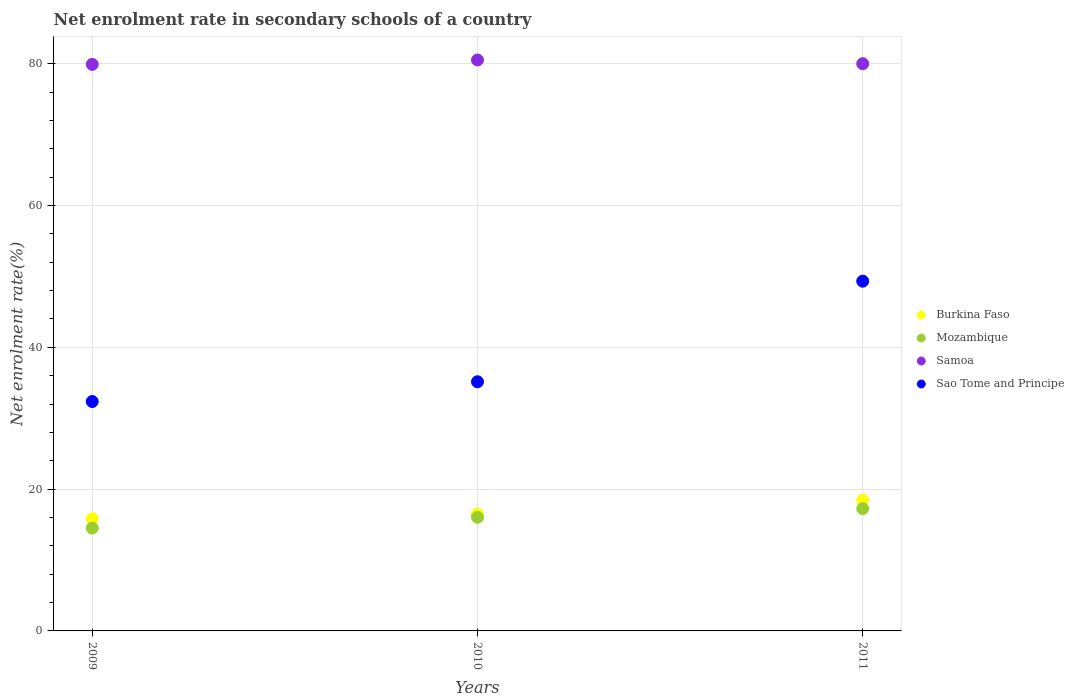How many different coloured dotlines are there?
Provide a short and direct response. 4. Is the number of dotlines equal to the number of legend labels?
Offer a terse response. Yes. What is the net enrolment rate in secondary schools in Burkina Faso in 2011?
Offer a very short reply. 18.45. Across all years, what is the maximum net enrolment rate in secondary schools in Samoa?
Your answer should be very brief. 80.53. Across all years, what is the minimum net enrolment rate in secondary schools in Samoa?
Offer a very short reply. 79.91. In which year was the net enrolment rate in secondary schools in Samoa maximum?
Your answer should be very brief. 2010. What is the total net enrolment rate in secondary schools in Sao Tome and Principe in the graph?
Make the answer very short. 116.84. What is the difference between the net enrolment rate in secondary schools in Burkina Faso in 2009 and that in 2011?
Provide a succinct answer. -2.62. What is the difference between the net enrolment rate in secondary schools in Samoa in 2011 and the net enrolment rate in secondary schools in Burkina Faso in 2009?
Your answer should be very brief. 64.18. What is the average net enrolment rate in secondary schools in Burkina Faso per year?
Ensure brevity in your answer.  16.92. In the year 2009, what is the difference between the net enrolment rate in secondary schools in Mozambique and net enrolment rate in secondary schools in Burkina Faso?
Make the answer very short. -1.31. What is the ratio of the net enrolment rate in secondary schools in Mozambique in 2009 to that in 2011?
Offer a very short reply. 0.84. What is the difference between the highest and the second highest net enrolment rate in secondary schools in Mozambique?
Offer a terse response. 1.23. What is the difference between the highest and the lowest net enrolment rate in secondary schools in Samoa?
Make the answer very short. 0.62. Is it the case that in every year, the sum of the net enrolment rate in secondary schools in Sao Tome and Principe and net enrolment rate in secondary schools in Samoa  is greater than the sum of net enrolment rate in secondary schools in Mozambique and net enrolment rate in secondary schools in Burkina Faso?
Your answer should be very brief. Yes. Is it the case that in every year, the sum of the net enrolment rate in secondary schools in Samoa and net enrolment rate in secondary schools in Burkina Faso  is greater than the net enrolment rate in secondary schools in Mozambique?
Provide a succinct answer. Yes. Does the net enrolment rate in secondary schools in Samoa monotonically increase over the years?
Offer a very short reply. No. Is the net enrolment rate in secondary schools in Mozambique strictly less than the net enrolment rate in secondary schools in Samoa over the years?
Give a very brief answer. Yes. How many dotlines are there?
Your answer should be very brief. 4. How many legend labels are there?
Offer a terse response. 4. How are the legend labels stacked?
Offer a terse response. Vertical. What is the title of the graph?
Offer a terse response. Net enrolment rate in secondary schools of a country. What is the label or title of the Y-axis?
Ensure brevity in your answer.  Net enrolment rate(%). What is the Net enrolment rate(%) of Burkina Faso in 2009?
Offer a terse response. 15.82. What is the Net enrolment rate(%) of Mozambique in 2009?
Give a very brief answer. 14.51. What is the Net enrolment rate(%) in Samoa in 2009?
Offer a terse response. 79.91. What is the Net enrolment rate(%) in Sao Tome and Principe in 2009?
Give a very brief answer. 32.36. What is the Net enrolment rate(%) of Burkina Faso in 2010?
Your response must be concise. 16.48. What is the Net enrolment rate(%) of Mozambique in 2010?
Offer a terse response. 16.03. What is the Net enrolment rate(%) in Samoa in 2010?
Provide a short and direct response. 80.53. What is the Net enrolment rate(%) in Sao Tome and Principe in 2010?
Offer a terse response. 35.14. What is the Net enrolment rate(%) in Burkina Faso in 2011?
Ensure brevity in your answer.  18.45. What is the Net enrolment rate(%) of Mozambique in 2011?
Make the answer very short. 17.25. What is the Net enrolment rate(%) of Samoa in 2011?
Ensure brevity in your answer.  80.01. What is the Net enrolment rate(%) of Sao Tome and Principe in 2011?
Provide a short and direct response. 49.33. Across all years, what is the maximum Net enrolment rate(%) in Burkina Faso?
Offer a very short reply. 18.45. Across all years, what is the maximum Net enrolment rate(%) in Mozambique?
Offer a very short reply. 17.25. Across all years, what is the maximum Net enrolment rate(%) of Samoa?
Ensure brevity in your answer.  80.53. Across all years, what is the maximum Net enrolment rate(%) in Sao Tome and Principe?
Your answer should be very brief. 49.33. Across all years, what is the minimum Net enrolment rate(%) in Burkina Faso?
Provide a succinct answer. 15.82. Across all years, what is the minimum Net enrolment rate(%) in Mozambique?
Your response must be concise. 14.51. Across all years, what is the minimum Net enrolment rate(%) in Samoa?
Your response must be concise. 79.91. Across all years, what is the minimum Net enrolment rate(%) in Sao Tome and Principe?
Give a very brief answer. 32.36. What is the total Net enrolment rate(%) in Burkina Faso in the graph?
Offer a terse response. 50.75. What is the total Net enrolment rate(%) in Mozambique in the graph?
Your response must be concise. 47.79. What is the total Net enrolment rate(%) of Samoa in the graph?
Provide a short and direct response. 240.45. What is the total Net enrolment rate(%) in Sao Tome and Principe in the graph?
Your answer should be very brief. 116.84. What is the difference between the Net enrolment rate(%) in Burkina Faso in 2009 and that in 2010?
Offer a very short reply. -0.65. What is the difference between the Net enrolment rate(%) in Mozambique in 2009 and that in 2010?
Make the answer very short. -1.52. What is the difference between the Net enrolment rate(%) in Samoa in 2009 and that in 2010?
Your answer should be very brief. -0.62. What is the difference between the Net enrolment rate(%) of Sao Tome and Principe in 2009 and that in 2010?
Provide a short and direct response. -2.79. What is the difference between the Net enrolment rate(%) of Burkina Faso in 2009 and that in 2011?
Your answer should be compact. -2.62. What is the difference between the Net enrolment rate(%) in Mozambique in 2009 and that in 2011?
Your answer should be very brief. -2.74. What is the difference between the Net enrolment rate(%) in Samoa in 2009 and that in 2011?
Offer a very short reply. -0.1. What is the difference between the Net enrolment rate(%) in Sao Tome and Principe in 2009 and that in 2011?
Make the answer very short. -16.98. What is the difference between the Net enrolment rate(%) of Burkina Faso in 2010 and that in 2011?
Give a very brief answer. -1.97. What is the difference between the Net enrolment rate(%) of Mozambique in 2010 and that in 2011?
Offer a terse response. -1.23. What is the difference between the Net enrolment rate(%) in Samoa in 2010 and that in 2011?
Your response must be concise. 0.52. What is the difference between the Net enrolment rate(%) in Sao Tome and Principe in 2010 and that in 2011?
Offer a very short reply. -14.19. What is the difference between the Net enrolment rate(%) in Burkina Faso in 2009 and the Net enrolment rate(%) in Mozambique in 2010?
Your response must be concise. -0.2. What is the difference between the Net enrolment rate(%) in Burkina Faso in 2009 and the Net enrolment rate(%) in Samoa in 2010?
Your answer should be compact. -64.71. What is the difference between the Net enrolment rate(%) in Burkina Faso in 2009 and the Net enrolment rate(%) in Sao Tome and Principe in 2010?
Provide a succinct answer. -19.32. What is the difference between the Net enrolment rate(%) of Mozambique in 2009 and the Net enrolment rate(%) of Samoa in 2010?
Ensure brevity in your answer.  -66.02. What is the difference between the Net enrolment rate(%) of Mozambique in 2009 and the Net enrolment rate(%) of Sao Tome and Principe in 2010?
Offer a terse response. -20.63. What is the difference between the Net enrolment rate(%) of Samoa in 2009 and the Net enrolment rate(%) of Sao Tome and Principe in 2010?
Ensure brevity in your answer.  44.77. What is the difference between the Net enrolment rate(%) in Burkina Faso in 2009 and the Net enrolment rate(%) in Mozambique in 2011?
Your response must be concise. -1.43. What is the difference between the Net enrolment rate(%) of Burkina Faso in 2009 and the Net enrolment rate(%) of Samoa in 2011?
Keep it short and to the point. -64.18. What is the difference between the Net enrolment rate(%) of Burkina Faso in 2009 and the Net enrolment rate(%) of Sao Tome and Principe in 2011?
Your response must be concise. -33.51. What is the difference between the Net enrolment rate(%) in Mozambique in 2009 and the Net enrolment rate(%) in Samoa in 2011?
Your answer should be very brief. -65.5. What is the difference between the Net enrolment rate(%) in Mozambique in 2009 and the Net enrolment rate(%) in Sao Tome and Principe in 2011?
Keep it short and to the point. -34.82. What is the difference between the Net enrolment rate(%) of Samoa in 2009 and the Net enrolment rate(%) of Sao Tome and Principe in 2011?
Provide a short and direct response. 30.58. What is the difference between the Net enrolment rate(%) of Burkina Faso in 2010 and the Net enrolment rate(%) of Mozambique in 2011?
Your answer should be compact. -0.78. What is the difference between the Net enrolment rate(%) in Burkina Faso in 2010 and the Net enrolment rate(%) in Samoa in 2011?
Offer a terse response. -63.53. What is the difference between the Net enrolment rate(%) of Burkina Faso in 2010 and the Net enrolment rate(%) of Sao Tome and Principe in 2011?
Make the answer very short. -32.86. What is the difference between the Net enrolment rate(%) in Mozambique in 2010 and the Net enrolment rate(%) in Samoa in 2011?
Provide a succinct answer. -63.98. What is the difference between the Net enrolment rate(%) in Mozambique in 2010 and the Net enrolment rate(%) in Sao Tome and Principe in 2011?
Offer a terse response. -33.31. What is the difference between the Net enrolment rate(%) in Samoa in 2010 and the Net enrolment rate(%) in Sao Tome and Principe in 2011?
Offer a terse response. 31.2. What is the average Net enrolment rate(%) in Burkina Faso per year?
Ensure brevity in your answer.  16.92. What is the average Net enrolment rate(%) in Mozambique per year?
Make the answer very short. 15.93. What is the average Net enrolment rate(%) of Samoa per year?
Provide a succinct answer. 80.15. What is the average Net enrolment rate(%) of Sao Tome and Principe per year?
Offer a terse response. 38.95. In the year 2009, what is the difference between the Net enrolment rate(%) of Burkina Faso and Net enrolment rate(%) of Mozambique?
Offer a very short reply. 1.31. In the year 2009, what is the difference between the Net enrolment rate(%) in Burkina Faso and Net enrolment rate(%) in Samoa?
Provide a succinct answer. -64.09. In the year 2009, what is the difference between the Net enrolment rate(%) in Burkina Faso and Net enrolment rate(%) in Sao Tome and Principe?
Your answer should be compact. -16.53. In the year 2009, what is the difference between the Net enrolment rate(%) of Mozambique and Net enrolment rate(%) of Samoa?
Your response must be concise. -65.4. In the year 2009, what is the difference between the Net enrolment rate(%) of Mozambique and Net enrolment rate(%) of Sao Tome and Principe?
Provide a short and direct response. -17.85. In the year 2009, what is the difference between the Net enrolment rate(%) in Samoa and Net enrolment rate(%) in Sao Tome and Principe?
Provide a succinct answer. 47.55. In the year 2010, what is the difference between the Net enrolment rate(%) in Burkina Faso and Net enrolment rate(%) in Mozambique?
Offer a very short reply. 0.45. In the year 2010, what is the difference between the Net enrolment rate(%) in Burkina Faso and Net enrolment rate(%) in Samoa?
Give a very brief answer. -64.05. In the year 2010, what is the difference between the Net enrolment rate(%) in Burkina Faso and Net enrolment rate(%) in Sao Tome and Principe?
Provide a short and direct response. -18.67. In the year 2010, what is the difference between the Net enrolment rate(%) in Mozambique and Net enrolment rate(%) in Samoa?
Your response must be concise. -64.51. In the year 2010, what is the difference between the Net enrolment rate(%) of Mozambique and Net enrolment rate(%) of Sao Tome and Principe?
Give a very brief answer. -19.12. In the year 2010, what is the difference between the Net enrolment rate(%) in Samoa and Net enrolment rate(%) in Sao Tome and Principe?
Offer a very short reply. 45.39. In the year 2011, what is the difference between the Net enrolment rate(%) in Burkina Faso and Net enrolment rate(%) in Mozambique?
Give a very brief answer. 1.19. In the year 2011, what is the difference between the Net enrolment rate(%) of Burkina Faso and Net enrolment rate(%) of Samoa?
Give a very brief answer. -61.56. In the year 2011, what is the difference between the Net enrolment rate(%) of Burkina Faso and Net enrolment rate(%) of Sao Tome and Principe?
Your answer should be compact. -30.89. In the year 2011, what is the difference between the Net enrolment rate(%) of Mozambique and Net enrolment rate(%) of Samoa?
Keep it short and to the point. -62.75. In the year 2011, what is the difference between the Net enrolment rate(%) in Mozambique and Net enrolment rate(%) in Sao Tome and Principe?
Offer a very short reply. -32.08. In the year 2011, what is the difference between the Net enrolment rate(%) in Samoa and Net enrolment rate(%) in Sao Tome and Principe?
Make the answer very short. 30.67. What is the ratio of the Net enrolment rate(%) in Burkina Faso in 2009 to that in 2010?
Make the answer very short. 0.96. What is the ratio of the Net enrolment rate(%) of Mozambique in 2009 to that in 2010?
Keep it short and to the point. 0.91. What is the ratio of the Net enrolment rate(%) of Samoa in 2009 to that in 2010?
Offer a terse response. 0.99. What is the ratio of the Net enrolment rate(%) in Sao Tome and Principe in 2009 to that in 2010?
Your answer should be compact. 0.92. What is the ratio of the Net enrolment rate(%) of Burkina Faso in 2009 to that in 2011?
Make the answer very short. 0.86. What is the ratio of the Net enrolment rate(%) of Mozambique in 2009 to that in 2011?
Make the answer very short. 0.84. What is the ratio of the Net enrolment rate(%) in Samoa in 2009 to that in 2011?
Your response must be concise. 1. What is the ratio of the Net enrolment rate(%) in Sao Tome and Principe in 2009 to that in 2011?
Provide a short and direct response. 0.66. What is the ratio of the Net enrolment rate(%) in Burkina Faso in 2010 to that in 2011?
Keep it short and to the point. 0.89. What is the ratio of the Net enrolment rate(%) in Mozambique in 2010 to that in 2011?
Make the answer very short. 0.93. What is the ratio of the Net enrolment rate(%) of Samoa in 2010 to that in 2011?
Give a very brief answer. 1.01. What is the ratio of the Net enrolment rate(%) in Sao Tome and Principe in 2010 to that in 2011?
Your answer should be very brief. 0.71. What is the difference between the highest and the second highest Net enrolment rate(%) in Burkina Faso?
Your answer should be very brief. 1.97. What is the difference between the highest and the second highest Net enrolment rate(%) of Mozambique?
Offer a very short reply. 1.23. What is the difference between the highest and the second highest Net enrolment rate(%) in Samoa?
Give a very brief answer. 0.52. What is the difference between the highest and the second highest Net enrolment rate(%) in Sao Tome and Principe?
Make the answer very short. 14.19. What is the difference between the highest and the lowest Net enrolment rate(%) in Burkina Faso?
Your answer should be compact. 2.62. What is the difference between the highest and the lowest Net enrolment rate(%) of Mozambique?
Give a very brief answer. 2.74. What is the difference between the highest and the lowest Net enrolment rate(%) of Samoa?
Give a very brief answer. 0.62. What is the difference between the highest and the lowest Net enrolment rate(%) in Sao Tome and Principe?
Give a very brief answer. 16.98. 